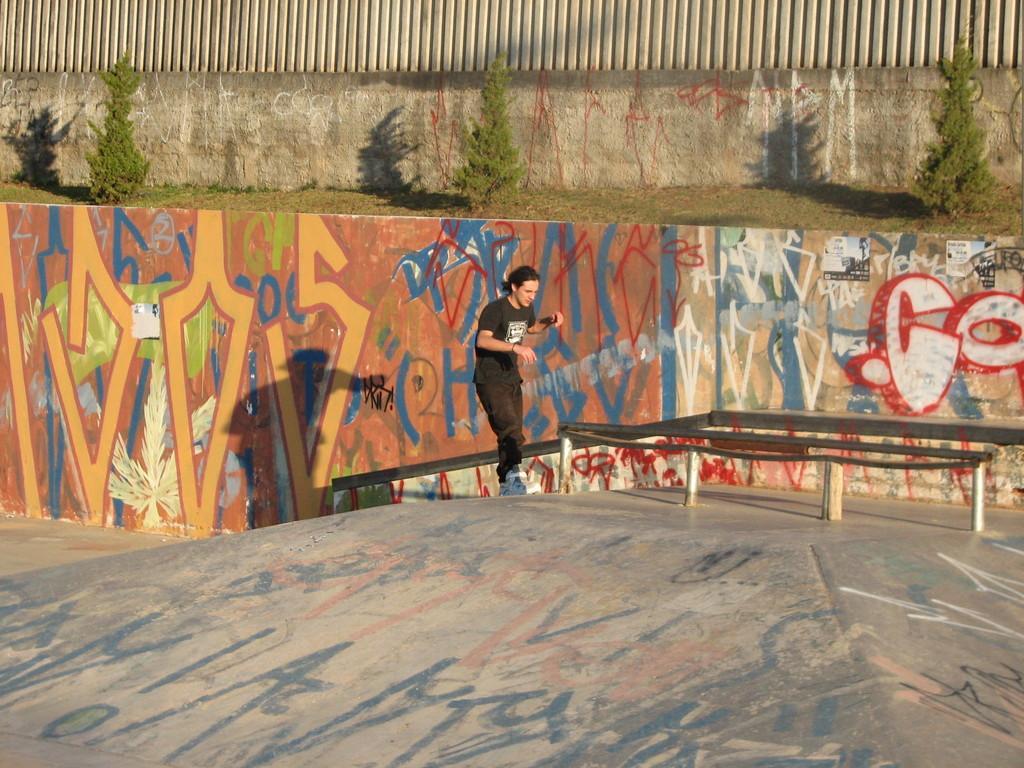Could you give a brief overview of what you see in this image? In this picture we can see a man standing on a platform, walls with paintings on it and in the background we can see trees. 